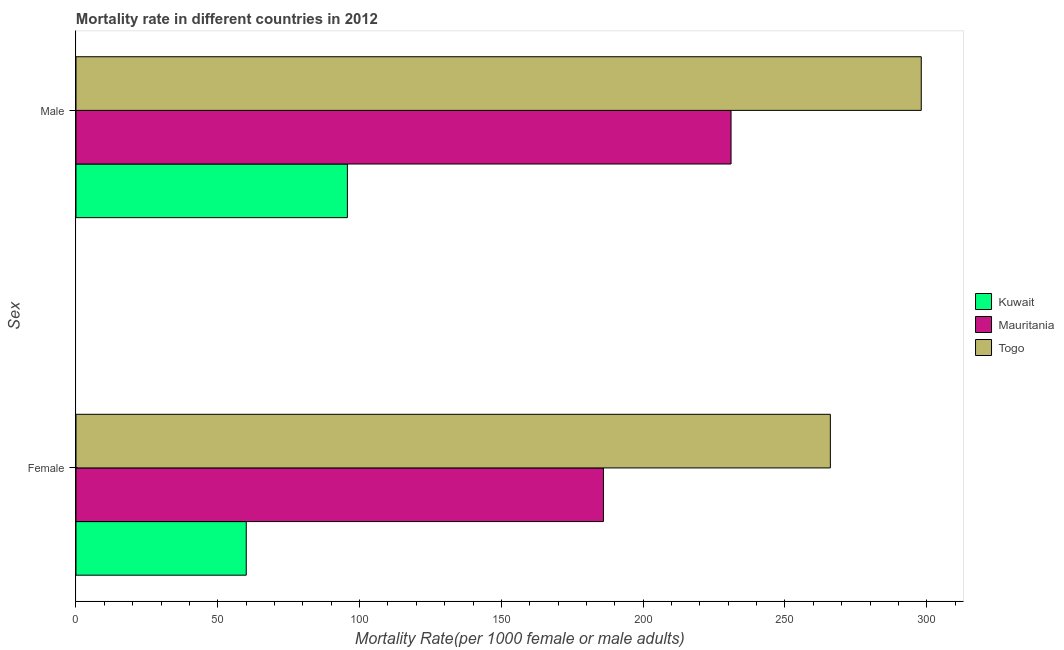How many different coloured bars are there?
Keep it short and to the point. 3. How many groups of bars are there?
Your response must be concise. 2. What is the label of the 2nd group of bars from the top?
Keep it short and to the point. Female. What is the male mortality rate in Togo?
Make the answer very short. 298.07. Across all countries, what is the maximum male mortality rate?
Offer a terse response. 298.07. Across all countries, what is the minimum male mortality rate?
Offer a terse response. 95.7. In which country was the female mortality rate maximum?
Offer a very short reply. Togo. In which country was the female mortality rate minimum?
Ensure brevity in your answer.  Kuwait. What is the total female mortality rate in the graph?
Make the answer very short. 512.06. What is the difference between the male mortality rate in Kuwait and that in Mauritania?
Give a very brief answer. -135.3. What is the difference between the male mortality rate in Mauritania and the female mortality rate in Togo?
Your answer should be compact. -35.02. What is the average female mortality rate per country?
Your response must be concise. 170.69. What is the difference between the female mortality rate and male mortality rate in Togo?
Give a very brief answer. -32.06. What is the ratio of the female mortality rate in Kuwait to that in Togo?
Keep it short and to the point. 0.23. Is the female mortality rate in Kuwait less than that in Togo?
Offer a very short reply. Yes. What does the 1st bar from the top in Female represents?
Give a very brief answer. Togo. What does the 1st bar from the bottom in Male represents?
Your response must be concise. Kuwait. How many bars are there?
Give a very brief answer. 6. Are all the bars in the graph horizontal?
Give a very brief answer. Yes. How many countries are there in the graph?
Your answer should be compact. 3. What is the difference between two consecutive major ticks on the X-axis?
Ensure brevity in your answer.  50. Does the graph contain grids?
Offer a very short reply. No. Where does the legend appear in the graph?
Provide a succinct answer. Center right. How many legend labels are there?
Give a very brief answer. 3. How are the legend labels stacked?
Keep it short and to the point. Vertical. What is the title of the graph?
Provide a short and direct response. Mortality rate in different countries in 2012. What is the label or title of the X-axis?
Give a very brief answer. Mortality Rate(per 1000 female or male adults). What is the label or title of the Y-axis?
Provide a succinct answer. Sex. What is the Mortality Rate(per 1000 female or male adults) in Kuwait in Female?
Your answer should be very brief. 60.04. What is the Mortality Rate(per 1000 female or male adults) of Mauritania in Female?
Give a very brief answer. 186. What is the Mortality Rate(per 1000 female or male adults) in Togo in Female?
Keep it short and to the point. 266.02. What is the Mortality Rate(per 1000 female or male adults) of Kuwait in Male?
Offer a terse response. 95.7. What is the Mortality Rate(per 1000 female or male adults) of Mauritania in Male?
Provide a short and direct response. 231. What is the Mortality Rate(per 1000 female or male adults) in Togo in Male?
Offer a very short reply. 298.07. Across all Sex, what is the maximum Mortality Rate(per 1000 female or male adults) in Kuwait?
Keep it short and to the point. 95.7. Across all Sex, what is the maximum Mortality Rate(per 1000 female or male adults) of Mauritania?
Provide a short and direct response. 231. Across all Sex, what is the maximum Mortality Rate(per 1000 female or male adults) of Togo?
Give a very brief answer. 298.07. Across all Sex, what is the minimum Mortality Rate(per 1000 female or male adults) of Kuwait?
Give a very brief answer. 60.04. Across all Sex, what is the minimum Mortality Rate(per 1000 female or male adults) in Mauritania?
Ensure brevity in your answer.  186. Across all Sex, what is the minimum Mortality Rate(per 1000 female or male adults) of Togo?
Ensure brevity in your answer.  266.02. What is the total Mortality Rate(per 1000 female or male adults) of Kuwait in the graph?
Provide a short and direct response. 155.75. What is the total Mortality Rate(per 1000 female or male adults) in Mauritania in the graph?
Offer a terse response. 417. What is the total Mortality Rate(per 1000 female or male adults) of Togo in the graph?
Keep it short and to the point. 564.09. What is the difference between the Mortality Rate(per 1000 female or male adults) in Kuwait in Female and that in Male?
Provide a short and direct response. -35.66. What is the difference between the Mortality Rate(per 1000 female or male adults) in Mauritania in Female and that in Male?
Keep it short and to the point. -45. What is the difference between the Mortality Rate(per 1000 female or male adults) of Togo in Female and that in Male?
Your response must be concise. -32.06. What is the difference between the Mortality Rate(per 1000 female or male adults) of Kuwait in Female and the Mortality Rate(per 1000 female or male adults) of Mauritania in Male?
Your response must be concise. -170.96. What is the difference between the Mortality Rate(per 1000 female or male adults) in Kuwait in Female and the Mortality Rate(per 1000 female or male adults) in Togo in Male?
Provide a succinct answer. -238.03. What is the difference between the Mortality Rate(per 1000 female or male adults) in Mauritania in Female and the Mortality Rate(per 1000 female or male adults) in Togo in Male?
Offer a terse response. -112.08. What is the average Mortality Rate(per 1000 female or male adults) in Kuwait per Sex?
Make the answer very short. 77.87. What is the average Mortality Rate(per 1000 female or male adults) in Mauritania per Sex?
Your response must be concise. 208.5. What is the average Mortality Rate(per 1000 female or male adults) of Togo per Sex?
Offer a very short reply. 282.05. What is the difference between the Mortality Rate(per 1000 female or male adults) of Kuwait and Mortality Rate(per 1000 female or male adults) of Mauritania in Female?
Give a very brief answer. -125.96. What is the difference between the Mortality Rate(per 1000 female or male adults) of Kuwait and Mortality Rate(per 1000 female or male adults) of Togo in Female?
Your response must be concise. -205.98. What is the difference between the Mortality Rate(per 1000 female or male adults) in Mauritania and Mortality Rate(per 1000 female or male adults) in Togo in Female?
Offer a very short reply. -80.02. What is the difference between the Mortality Rate(per 1000 female or male adults) of Kuwait and Mortality Rate(per 1000 female or male adults) of Mauritania in Male?
Your answer should be very brief. -135.3. What is the difference between the Mortality Rate(per 1000 female or male adults) of Kuwait and Mortality Rate(per 1000 female or male adults) of Togo in Male?
Your answer should be compact. -202.37. What is the difference between the Mortality Rate(per 1000 female or male adults) of Mauritania and Mortality Rate(per 1000 female or male adults) of Togo in Male?
Provide a short and direct response. -67.07. What is the ratio of the Mortality Rate(per 1000 female or male adults) in Kuwait in Female to that in Male?
Your response must be concise. 0.63. What is the ratio of the Mortality Rate(per 1000 female or male adults) in Mauritania in Female to that in Male?
Your answer should be very brief. 0.81. What is the ratio of the Mortality Rate(per 1000 female or male adults) in Togo in Female to that in Male?
Offer a very short reply. 0.89. What is the difference between the highest and the second highest Mortality Rate(per 1000 female or male adults) of Kuwait?
Your answer should be very brief. 35.66. What is the difference between the highest and the second highest Mortality Rate(per 1000 female or male adults) of Mauritania?
Keep it short and to the point. 45. What is the difference between the highest and the second highest Mortality Rate(per 1000 female or male adults) in Togo?
Ensure brevity in your answer.  32.06. What is the difference between the highest and the lowest Mortality Rate(per 1000 female or male adults) of Kuwait?
Your answer should be very brief. 35.66. What is the difference between the highest and the lowest Mortality Rate(per 1000 female or male adults) of Mauritania?
Your answer should be compact. 45. What is the difference between the highest and the lowest Mortality Rate(per 1000 female or male adults) in Togo?
Offer a very short reply. 32.06. 